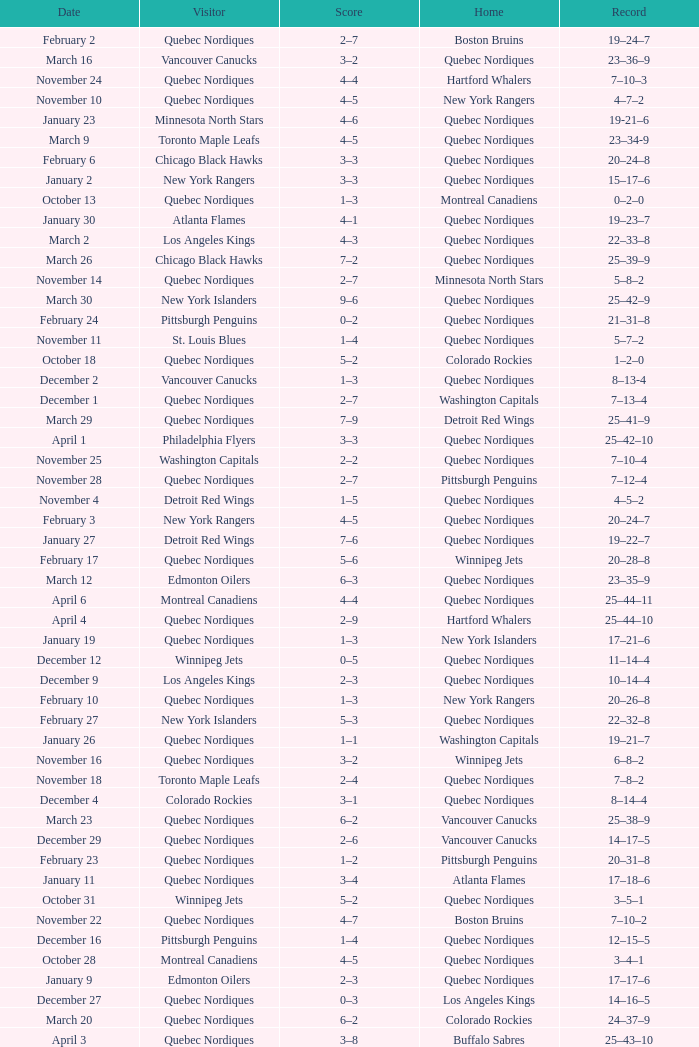Which Record has a Home of edmonton oilers, and a Score of 3–6? 1–3–0. 